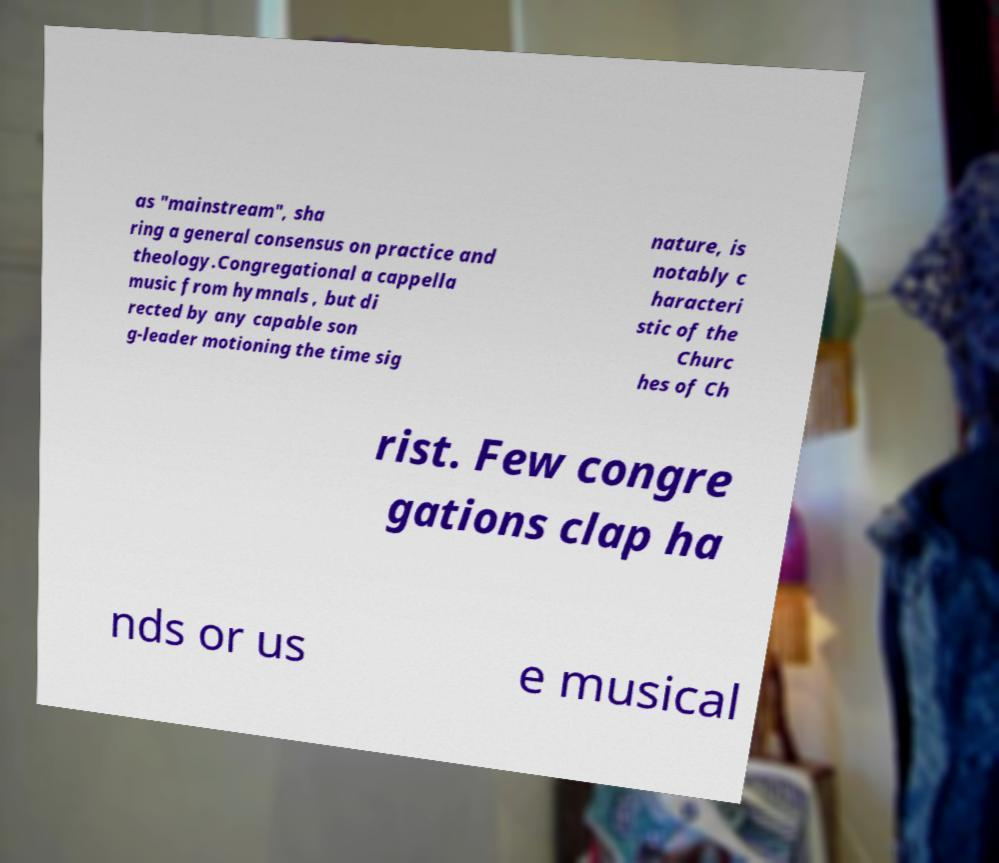Please read and relay the text visible in this image. What does it say? as "mainstream", sha ring a general consensus on practice and theology.Congregational a cappella music from hymnals , but di rected by any capable son g-leader motioning the time sig nature, is notably c haracteri stic of the Churc hes of Ch rist. Few congre gations clap ha nds or us e musical 